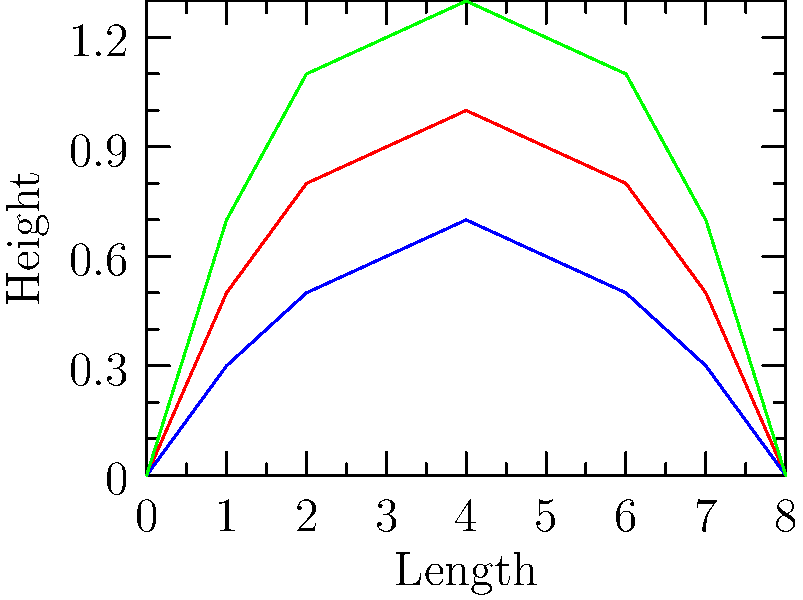Based on the streamline plots shown, which vehicle body shape would likely have the lowest drag coefficient, and how might this impact the energy efficiency of our electric vehicles? To answer this question, we need to analyze the streamline plots for each vehicle body shape:

1. The red line represents a sedan, showing a moderate curve.
2. The blue line represents a sports car, displaying the lowest and most gradual curve.
3. The green line represents an SUV, exhibiting the highest and steepest curve.

The drag coefficient ($C_d$) is directly related to the vehicle's aerodynamic profile. A lower, smoother curve indicates less air resistance and thus a lower drag coefficient.

Step-by-step analysis:
1. The sports car (blue line) has the lowest profile, meaning it disturbs the airflow the least.
2. The sedan (red line) has a slightly higher profile than the sports car but lower than the SUV.
3. The SUV (green line) has the highest profile, indicating it would face the most air resistance.

In terms of energy efficiency for electric vehicles:
1. Lower drag coefficient means less energy is required to overcome air resistance.
2. This translates to improved range per charge for electric vehicles.
3. It also allows for potentially smaller battery packs, reducing vehicle weight and cost.

Therefore, the sports car design would likely be the most energy-efficient, followed by the sedan, and then the SUV.
Answer: Sports car; lower drag coefficient improves energy efficiency and range. 